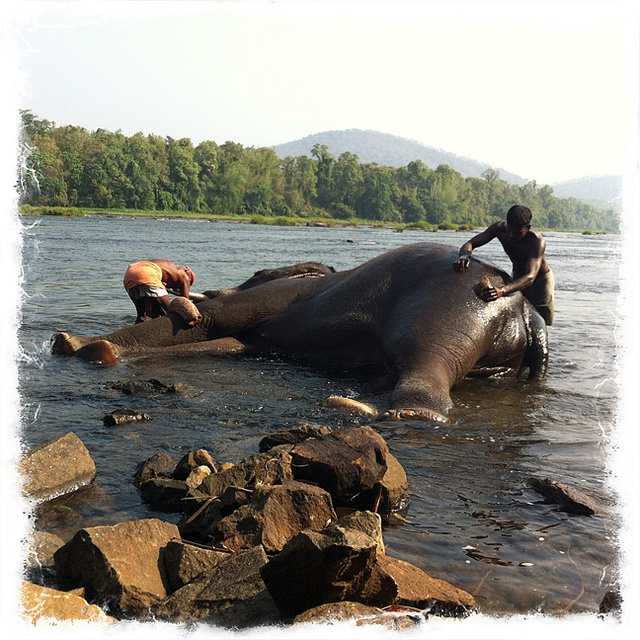Describe the objects in this image and their specific colors. I can see elephant in white, black, gray, and maroon tones, people in white, black, gray, lightgray, and darkgray tones, and people in white, black, tan, maroon, and khaki tones in this image. 